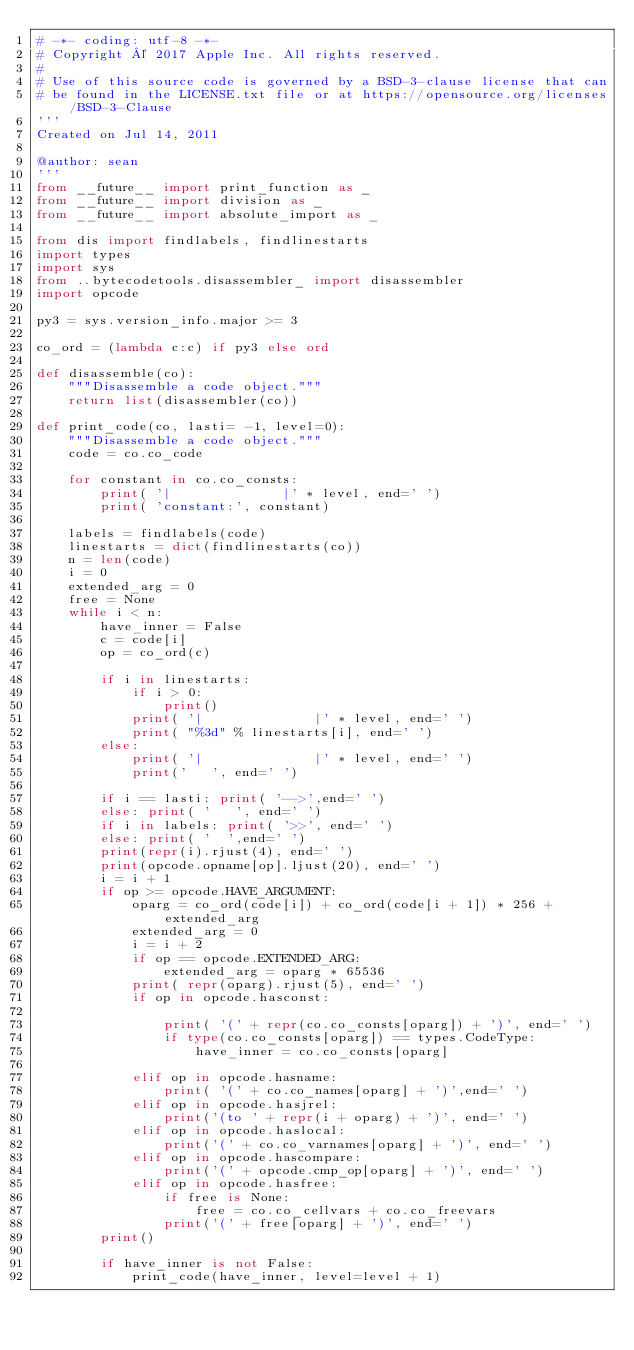<code> <loc_0><loc_0><loc_500><loc_500><_Python_># -*- coding: utf-8 -*-
# Copyright © 2017 Apple Inc. All rights reserved.
#
# Use of this source code is governed by a BSD-3-clause license that can
# be found in the LICENSE.txt file or at https://opensource.org/licenses/BSD-3-Clause
'''
Created on Jul 14, 2011

@author: sean
'''
from __future__ import print_function as _
from __future__ import division as _
from __future__ import absolute_import as _

from dis import findlabels, findlinestarts
import types
import sys
from ..bytecodetools.disassembler_ import disassembler
import opcode

py3 = sys.version_info.major >= 3

co_ord = (lambda c:c) if py3 else ord

def disassemble(co):
    """Disassemble a code object."""
    return list(disassembler(co))

def print_code(co, lasti= -1, level=0):
    """Disassemble a code object."""
    code = co.co_code

    for constant in co.co_consts:
        print( '|              |' * level, end=' ')
        print( 'constant:', constant)

    labels = findlabels(code)
    linestarts = dict(findlinestarts(co))
    n = len(code)
    i = 0
    extended_arg = 0
    free = None
    while i < n:
        have_inner = False
        c = code[i]
        op = co_ord(c)

        if i in linestarts:
            if i > 0:
                print()
            print( '|              |' * level, end=' ')
            print( "%3d" % linestarts[i], end=' ')
        else:
            print( '|              |' * level, end=' ')
            print('   ', end=' ')

        if i == lasti: print( '-->',end=' ')
        else: print( '   ', end=' ')
        if i in labels: print( '>>', end=' ')
        else: print( '  ',end=' ')
        print(repr(i).rjust(4), end=' ')
        print(opcode.opname[op].ljust(20), end=' ')
        i = i + 1
        if op >= opcode.HAVE_ARGUMENT:
            oparg = co_ord(code[i]) + co_ord(code[i + 1]) * 256 + extended_arg
            extended_arg = 0
            i = i + 2
            if op == opcode.EXTENDED_ARG:
                extended_arg = oparg * 65536
            print( repr(oparg).rjust(5), end=' ')
            if op in opcode.hasconst:

                print( '(' + repr(co.co_consts[oparg]) + ')', end=' ')
                if type(co.co_consts[oparg]) == types.CodeType:
                    have_inner = co.co_consts[oparg]

            elif op in opcode.hasname:
                print( '(' + co.co_names[oparg] + ')',end=' ')
            elif op in opcode.hasjrel:
                print('(to ' + repr(i + oparg) + ')', end=' ')
            elif op in opcode.haslocal:
                print('(' + co.co_varnames[oparg] + ')', end=' ')
            elif op in opcode.hascompare:
                print('(' + opcode.cmp_op[oparg] + ')', end=' ')
            elif op in opcode.hasfree:
                if free is None:
                    free = co.co_cellvars + co.co_freevars
                print('(' + free[oparg] + ')', end=' ')
        print()

        if have_inner is not False:
            print_code(have_inner, level=level + 1)
</code> 